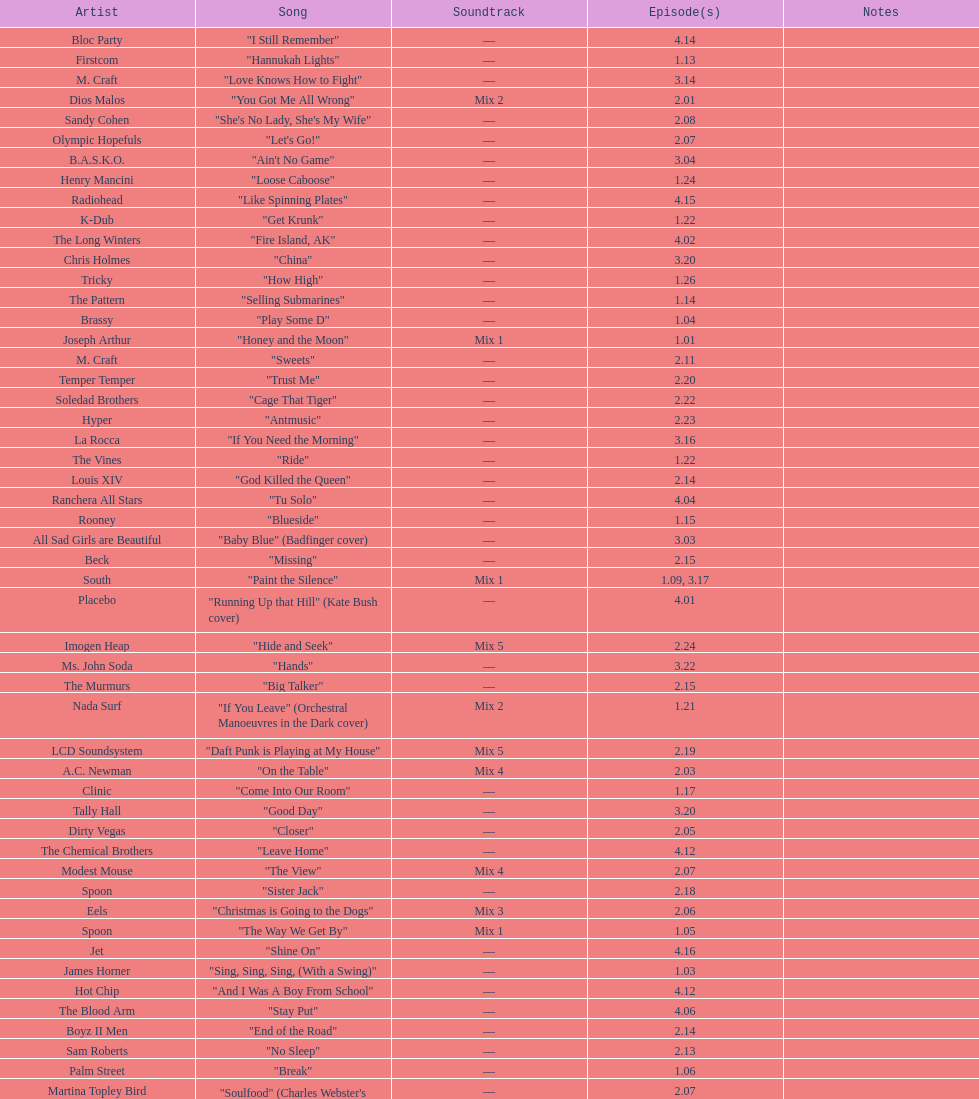The artist ash only had one song that appeared in the o.c. what is the name of that song? "Burn Baby Burn". 